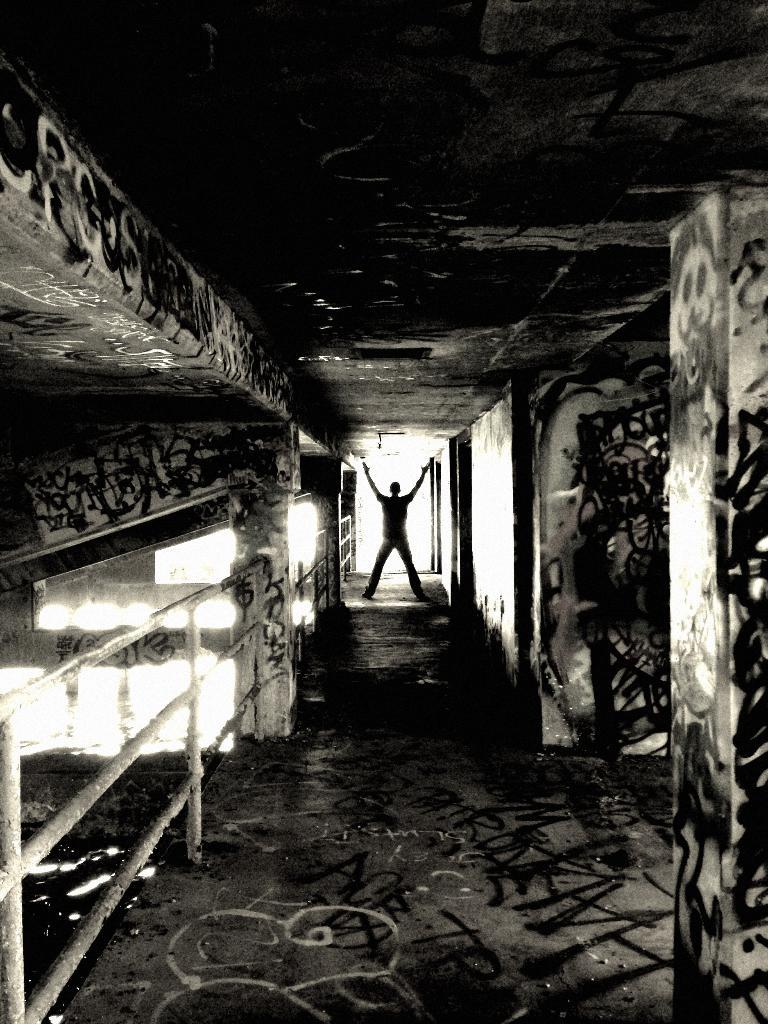What is the main subject of the image? There is a person standing in the image. What is the background of the image? There is a wall in the image. What is the surface on which the person is standing? There is a floor in the image. What type of chess piece is the person holding in the image? There is no chess piece present in the image; the person is not holding anything. 